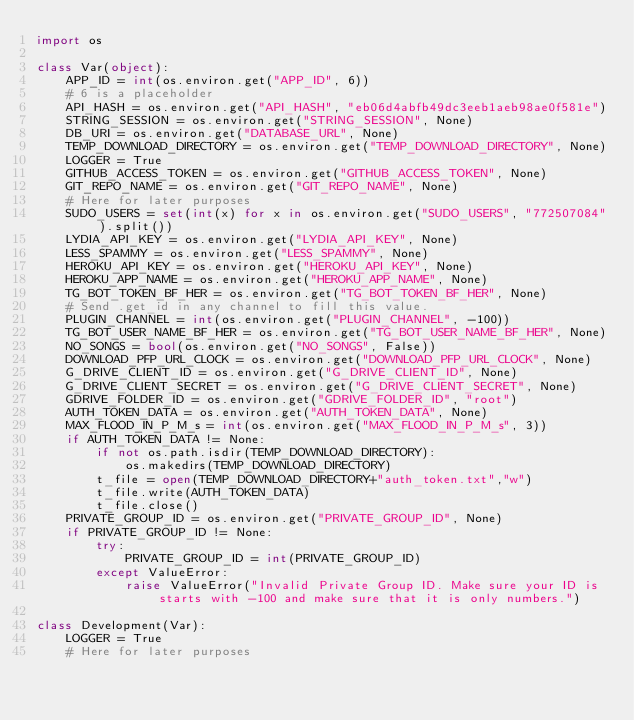Convert code to text. <code><loc_0><loc_0><loc_500><loc_500><_Python_>import os

class Var(object):
    APP_ID = int(os.environ.get("APP_ID", 6))
    # 6 is a placeholder
    API_HASH = os.environ.get("API_HASH", "eb06d4abfb49dc3eeb1aeb98ae0f581e")
    STRING_SESSION = os.environ.get("STRING_SESSION", None)
    DB_URI = os.environ.get("DATABASE_URL", None)
    TEMP_DOWNLOAD_DIRECTORY = os.environ.get("TEMP_DOWNLOAD_DIRECTORY", None)
    LOGGER = True
    GITHUB_ACCESS_TOKEN = os.environ.get("GITHUB_ACCESS_TOKEN", None)
    GIT_REPO_NAME = os.environ.get("GIT_REPO_NAME", None)
    # Here for later purposes
    SUDO_USERS = set(int(x) for x in os.environ.get("SUDO_USERS", "772507084").split())
    LYDIA_API_KEY = os.environ.get("LYDIA_API_KEY", None)
    LESS_SPAMMY = os.environ.get("LESS_SPAMMY", None)
    HEROKU_API_KEY = os.environ.get("HEROKU_API_KEY", None)
    HEROKU_APP_NAME = os.environ.get("HEROKU_APP_NAME", None)
    TG_BOT_TOKEN_BF_HER = os.environ.get("TG_BOT_TOKEN_BF_HER", None)
    # Send .get_id in any channel to fill this value.
    PLUGIN_CHANNEL = int(os.environ.get("PLUGIN_CHANNEL", -100))
    TG_BOT_USER_NAME_BF_HER = os.environ.get("TG_BOT_USER_NAME_BF_HER", None)
    NO_SONGS = bool(os.environ.get("NO_SONGS", False))
    DOWNLOAD_PFP_URL_CLOCK = os.environ.get("DOWNLOAD_PFP_URL_CLOCK", None)
    G_DRIVE_CLIENT_ID = os.environ.get("G_DRIVE_CLIENT_ID", None)
    G_DRIVE_CLIENT_SECRET = os.environ.get("G_DRIVE_CLIENT_SECRET", None)
    GDRIVE_FOLDER_ID = os.environ.get("GDRIVE_FOLDER_ID", "root")
    AUTH_TOKEN_DATA = os.environ.get("AUTH_TOKEN_DATA", None)
    MAX_FLOOD_IN_P_M_s = int(os.environ.get("MAX_FLOOD_IN_P_M_s", 3))
    if AUTH_TOKEN_DATA != None:
        if not os.path.isdir(TEMP_DOWNLOAD_DIRECTORY):
            os.makedirs(TEMP_DOWNLOAD_DIRECTORY)
        t_file = open(TEMP_DOWNLOAD_DIRECTORY+"auth_token.txt","w")
        t_file.write(AUTH_TOKEN_DATA)
        t_file.close()
    PRIVATE_GROUP_ID = os.environ.get("PRIVATE_GROUP_ID", None)
    if PRIVATE_GROUP_ID != None:
        try:
            PRIVATE_GROUP_ID = int(PRIVATE_GROUP_ID)
        except ValueError:
            raise ValueError("Invalid Private Group ID. Make sure your ID is starts with -100 and make sure that it is only numbers.")

class Development(Var):
    LOGGER = True
    # Here for later purposes
</code> 